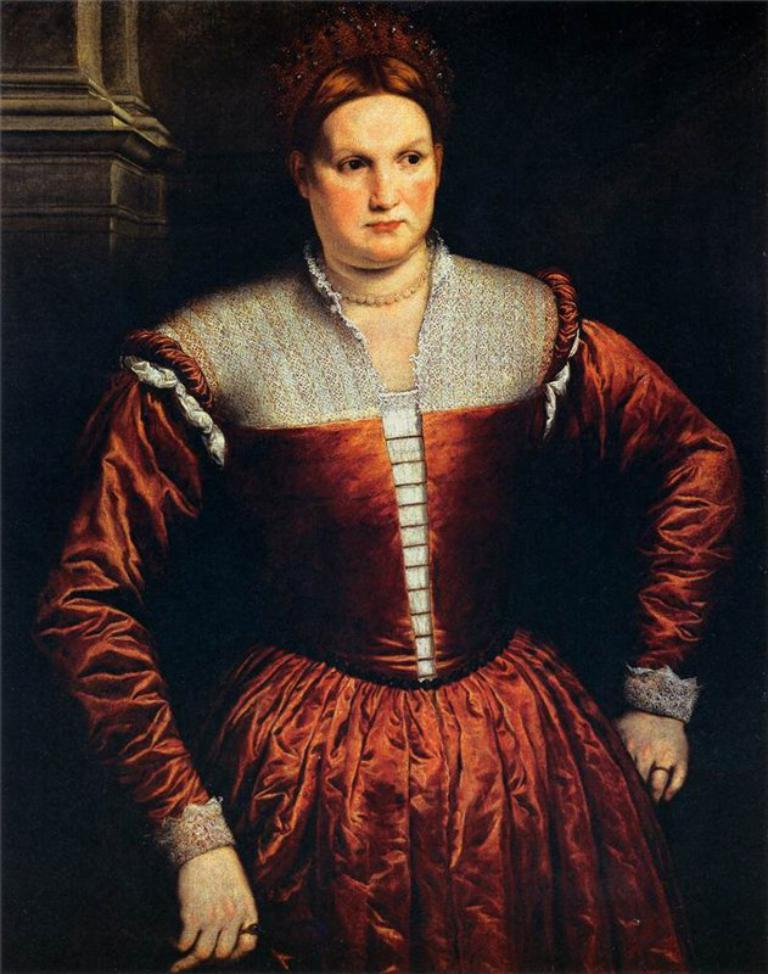What is the main subject of the image? The main subject of the image is a picture of a woman. What is the woman wearing in the image? The woman is wearing a red dress in the image. What can be seen in the background of the image? There is a pillar in the background of the image. How would you describe the overall lighting in the image? The background of the image is dark. What type of account does the woman have with her friend in the image? There is no indication of an account or a friend in the image; it features a picture of a woman wearing a red dress with a pillar in the background. How many roses can be seen in the woman's hand in the image? There are no roses present in the image. 